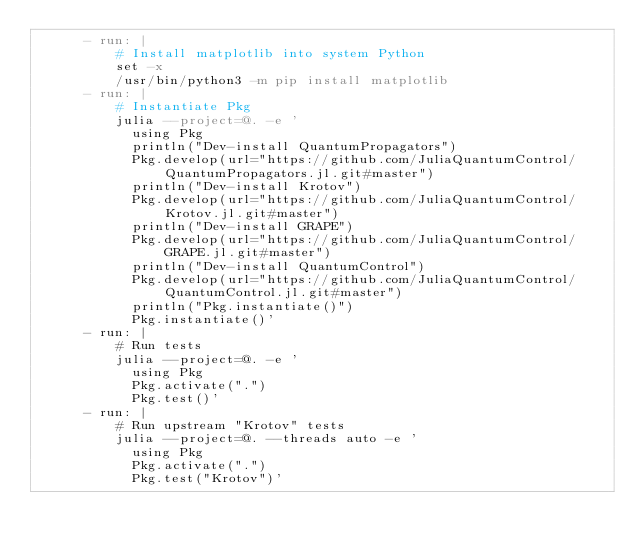Convert code to text. <code><loc_0><loc_0><loc_500><loc_500><_YAML_>      - run: |
          # Install matplotlib into system Python
          set -x
          /usr/bin/python3 -m pip install matplotlib
      - run: |
          # Instantiate Pkg
          julia --project=@. -e '
            using Pkg
            println("Dev-install QuantumPropagators")
            Pkg.develop(url="https://github.com/JuliaQuantumControl/QuantumPropagators.jl.git#master")
            println("Dev-install Krotov")
            Pkg.develop(url="https://github.com/JuliaQuantumControl/Krotov.jl.git#master")
            println("Dev-install GRAPE")
            Pkg.develop(url="https://github.com/JuliaQuantumControl/GRAPE.jl.git#master")
            println("Dev-install QuantumControl")
            Pkg.develop(url="https://github.com/JuliaQuantumControl/QuantumControl.jl.git#master")
            println("Pkg.instantiate()")
            Pkg.instantiate()'
      - run: |
          # Run tests
          julia --project=@. -e '
            using Pkg
            Pkg.activate(".")
            Pkg.test()'
      - run: |
          # Run upstream "Krotov" tests
          julia --project=@. --threads auto -e '
            using Pkg
            Pkg.activate(".")
            Pkg.test("Krotov")'
</code> 